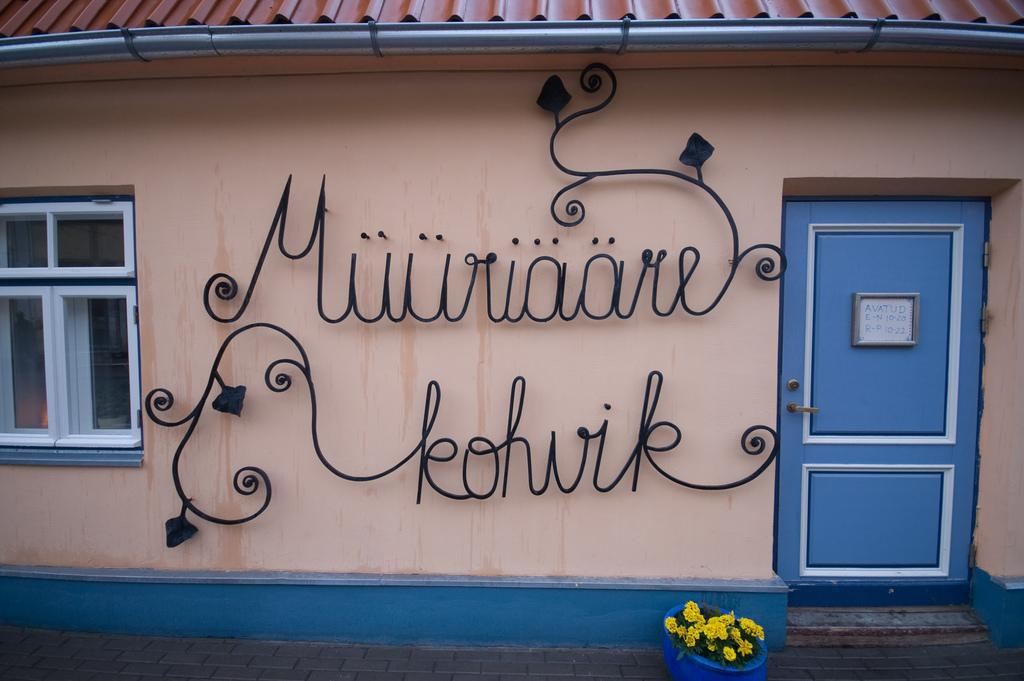What type of plant is in the pot in the image? There is a plant with flowers in a pot in the image. How is the plant situated in the image? The plant is in a pot. What structure is visible in the image? There is a building in the image. What features can be seen on the building? The building has name boards, a door, and a window. What type of cushion is being used by the lawyer in the image? There is no lawyer or cushion present in the image. 